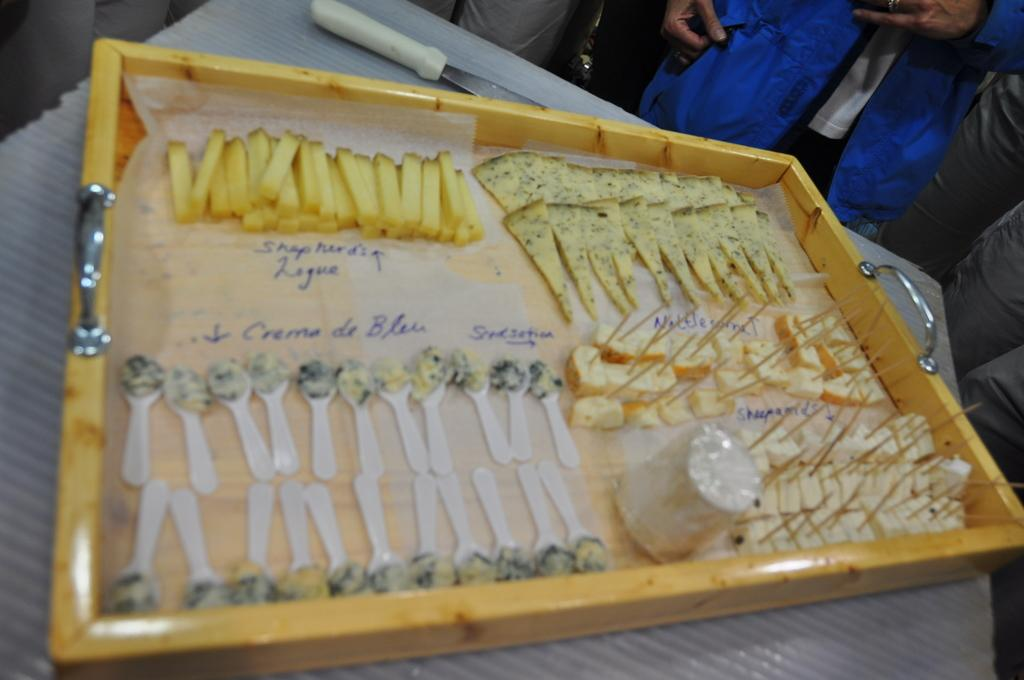What types of items can be seen in the image? There are different food items, spoons, and papers in the tray in the image. What is used for eating the food items? There are spoons in the image that can be used for eating. What is holding the food items and spoons? There is a tray in the image that holds the food items and spoons. What object is present on the table? There is an object on the table, but the specific object is not mentioned in the facts. Can you describe the people in the image? There is a group of people standing at the back of the image. What type of glass is being used to catch the attention of the people in the image? There is no glass present in the image, and no one is trying to catch anyone's attention. 